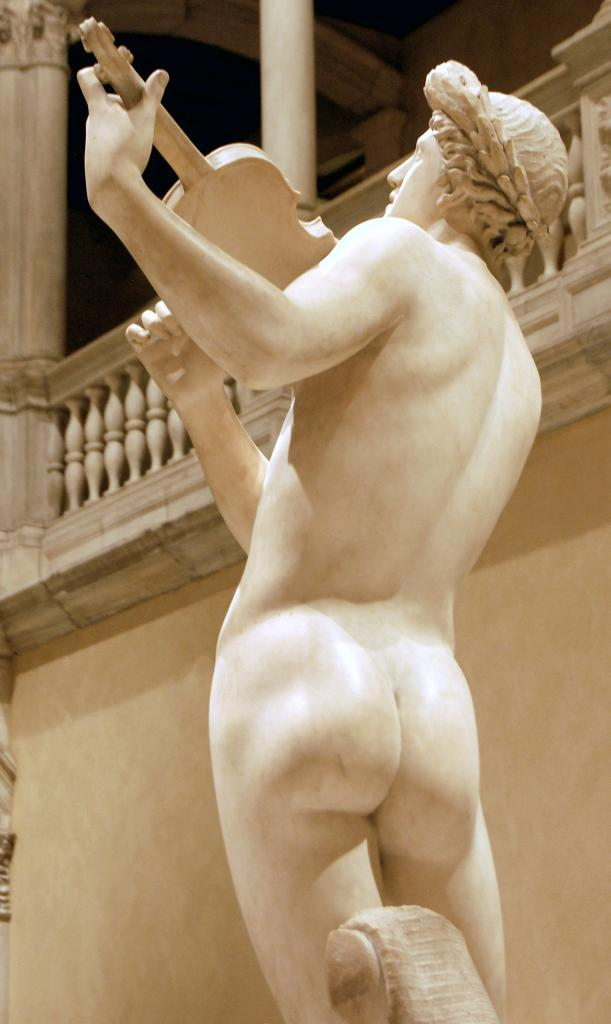What is the main subject of the image? There is a statue in the image. What material is the statue made of? The statue is made of white marble. What is the chance of the statue bleeding in the image? There is no blood or indication of bleeding in the image, as the statue is made of white marble and is not a living being. 